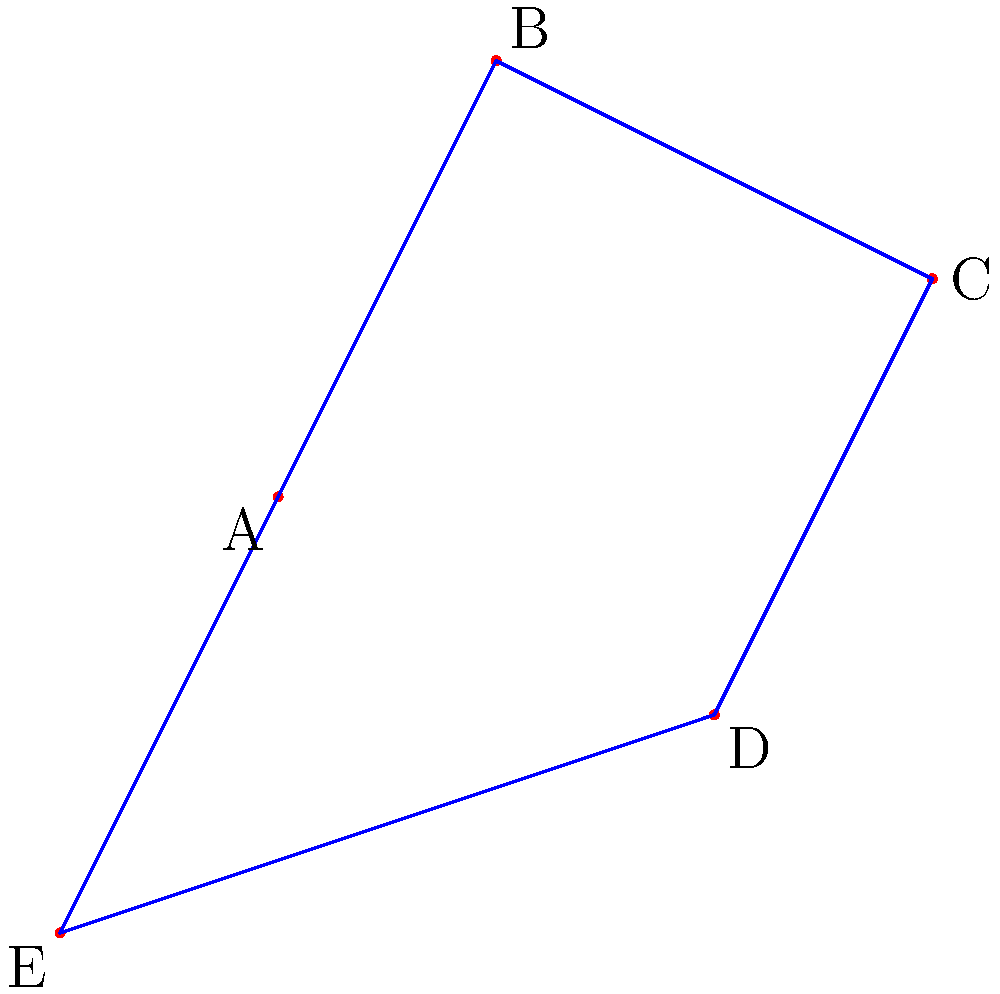As a tech enthusiast exploring astronomy apps on your new device, you come across this star pattern. Which well-known constellation does it represent? To identify this constellation, let's analyze the star pattern step-by-step:

1. The diagram shows five bright stars (A, B, C, D, and E) connected by lines to form a distinct shape.

2. The overall shape resembles a house-like structure or an inverted "V" with an extended base.

3. Star A forms the bottom-left corner, while star E forms the bottom-right corner of the base.

4. Stars B and C form the peak of the inverted "V" shape.

5. Star D extends from the right side, creating an asymmetrical appearance.

This distinctive pattern is characteristic of the constellation Cassiopeia, named after the vain queen in Greek mythology. Cassiopeia is one of the most recognizable constellations in the northern sky, often described as a "W" or "M" shape, depending on its orientation.

In this representation, we see it in its "house" or "crown" orientation, which is one of the ways it appears in the night sky throughout the year due to Earth's rotation.

Cassiopeia is circumpolar in most of the northern hemisphere, meaning it never sets below the horizon and can be seen year-round, making it an excellent reference point for amateur astronomers and stargazers.
Answer: Cassiopeia 